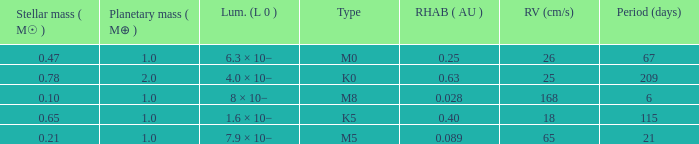What is the total stellar mass of the type m0? 0.47. 